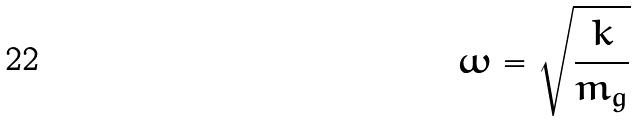Convert formula to latex. <formula><loc_0><loc_0><loc_500><loc_500>\omega = \sqrt { \frac { k } { m _ { g } } }</formula> 